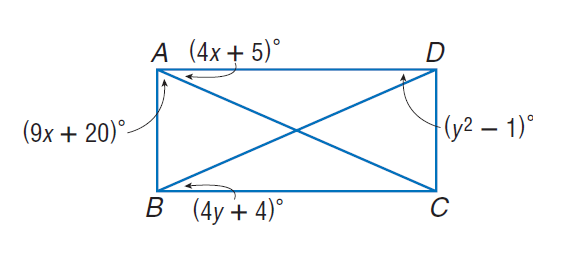Answer the mathemtical geometry problem and directly provide the correct option letter.
Question: Quadrilateral A B C D is a rectangle. Find y.
Choices: A: 5 B: 10 C: 15 D: 20 A 